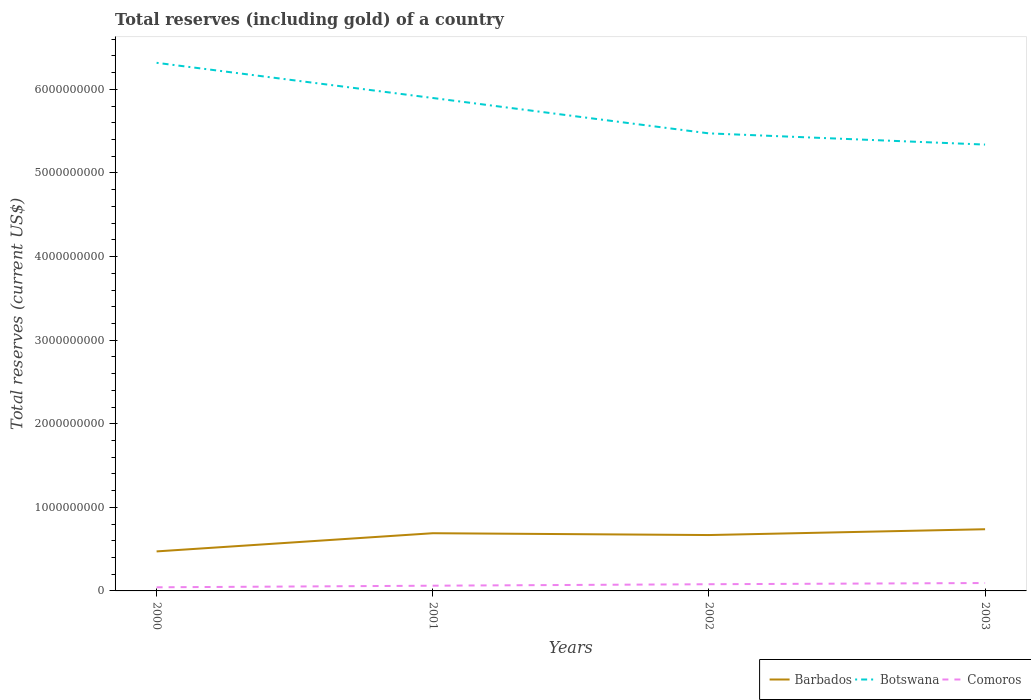Is the number of lines equal to the number of legend labels?
Your answer should be compact. Yes. Across all years, what is the maximum total reserves (including gold) in Barbados?
Offer a very short reply. 4.73e+08. In which year was the total reserves (including gold) in Comoros maximum?
Your response must be concise. 2000. What is the total total reserves (including gold) in Comoros in the graph?
Offer a terse response. -3.21e+07. What is the difference between the highest and the second highest total reserves (including gold) in Botswana?
Your response must be concise. 9.78e+08. What is the difference between the highest and the lowest total reserves (including gold) in Barbados?
Give a very brief answer. 3. How many years are there in the graph?
Your response must be concise. 4. What is the difference between two consecutive major ticks on the Y-axis?
Your response must be concise. 1.00e+09. Are the values on the major ticks of Y-axis written in scientific E-notation?
Your response must be concise. No. Does the graph contain any zero values?
Provide a short and direct response. No. Does the graph contain grids?
Ensure brevity in your answer.  No. How many legend labels are there?
Give a very brief answer. 3. How are the legend labels stacked?
Provide a short and direct response. Horizontal. What is the title of the graph?
Offer a very short reply. Total reserves (including gold) of a country. Does "Low & middle income" appear as one of the legend labels in the graph?
Offer a very short reply. No. What is the label or title of the Y-axis?
Your answer should be very brief. Total reserves (current US$). What is the Total reserves (current US$) of Barbados in 2000?
Your answer should be compact. 4.73e+08. What is the Total reserves (current US$) of Botswana in 2000?
Give a very brief answer. 6.32e+09. What is the Total reserves (current US$) in Comoros in 2000?
Your answer should be compact. 4.34e+07. What is the Total reserves (current US$) of Barbados in 2001?
Your answer should be compact. 6.90e+08. What is the Total reserves (current US$) of Botswana in 2001?
Ensure brevity in your answer.  5.90e+09. What is the Total reserves (current US$) of Comoros in 2001?
Your response must be concise. 6.25e+07. What is the Total reserves (current US$) in Barbados in 2002?
Keep it short and to the point. 6.69e+08. What is the Total reserves (current US$) in Botswana in 2002?
Provide a succinct answer. 5.47e+09. What is the Total reserves (current US$) in Comoros in 2002?
Your answer should be compact. 8.01e+07. What is the Total reserves (current US$) of Barbados in 2003?
Offer a terse response. 7.38e+08. What is the Total reserves (current US$) of Botswana in 2003?
Give a very brief answer. 5.34e+09. What is the Total reserves (current US$) of Comoros in 2003?
Give a very brief answer. 9.45e+07. Across all years, what is the maximum Total reserves (current US$) of Barbados?
Your response must be concise. 7.38e+08. Across all years, what is the maximum Total reserves (current US$) in Botswana?
Provide a short and direct response. 6.32e+09. Across all years, what is the maximum Total reserves (current US$) of Comoros?
Offer a terse response. 9.45e+07. Across all years, what is the minimum Total reserves (current US$) in Barbados?
Your answer should be very brief. 4.73e+08. Across all years, what is the minimum Total reserves (current US$) in Botswana?
Give a very brief answer. 5.34e+09. Across all years, what is the minimum Total reserves (current US$) in Comoros?
Offer a very short reply. 4.34e+07. What is the total Total reserves (current US$) in Barbados in the graph?
Your answer should be very brief. 2.57e+09. What is the total Total reserves (current US$) of Botswana in the graph?
Your answer should be compact. 2.30e+1. What is the total Total reserves (current US$) in Comoros in the graph?
Your answer should be compact. 2.81e+08. What is the difference between the Total reserves (current US$) of Barbados in 2000 and that in 2001?
Offer a very short reply. -2.18e+08. What is the difference between the Total reserves (current US$) in Botswana in 2000 and that in 2001?
Keep it short and to the point. 4.21e+08. What is the difference between the Total reserves (current US$) in Comoros in 2000 and that in 2001?
Your answer should be compact. -1.91e+07. What is the difference between the Total reserves (current US$) of Barbados in 2000 and that in 2002?
Offer a very short reply. -1.96e+08. What is the difference between the Total reserves (current US$) in Botswana in 2000 and that in 2002?
Give a very brief answer. 8.44e+08. What is the difference between the Total reserves (current US$) in Comoros in 2000 and that in 2002?
Your response must be concise. -3.68e+07. What is the difference between the Total reserves (current US$) in Barbados in 2000 and that in 2003?
Your answer should be compact. -2.65e+08. What is the difference between the Total reserves (current US$) in Botswana in 2000 and that in 2003?
Your response must be concise. 9.78e+08. What is the difference between the Total reserves (current US$) of Comoros in 2000 and that in 2003?
Offer a terse response. -5.12e+07. What is the difference between the Total reserves (current US$) of Barbados in 2001 and that in 2002?
Ensure brevity in your answer.  2.19e+07. What is the difference between the Total reserves (current US$) of Botswana in 2001 and that in 2002?
Keep it short and to the point. 4.23e+08. What is the difference between the Total reserves (current US$) in Comoros in 2001 and that in 2002?
Offer a very short reply. -1.77e+07. What is the difference between the Total reserves (current US$) in Barbados in 2001 and that in 2003?
Ensure brevity in your answer.  -4.76e+07. What is the difference between the Total reserves (current US$) in Botswana in 2001 and that in 2003?
Your response must be concise. 5.57e+08. What is the difference between the Total reserves (current US$) in Comoros in 2001 and that in 2003?
Offer a very short reply. -3.21e+07. What is the difference between the Total reserves (current US$) of Barbados in 2002 and that in 2003?
Keep it short and to the point. -6.94e+07. What is the difference between the Total reserves (current US$) of Botswana in 2002 and that in 2003?
Provide a succinct answer. 1.34e+08. What is the difference between the Total reserves (current US$) of Comoros in 2002 and that in 2003?
Make the answer very short. -1.44e+07. What is the difference between the Total reserves (current US$) of Barbados in 2000 and the Total reserves (current US$) of Botswana in 2001?
Keep it short and to the point. -5.42e+09. What is the difference between the Total reserves (current US$) of Barbados in 2000 and the Total reserves (current US$) of Comoros in 2001?
Keep it short and to the point. 4.10e+08. What is the difference between the Total reserves (current US$) of Botswana in 2000 and the Total reserves (current US$) of Comoros in 2001?
Offer a very short reply. 6.26e+09. What is the difference between the Total reserves (current US$) of Barbados in 2000 and the Total reserves (current US$) of Botswana in 2002?
Your answer should be very brief. -5.00e+09. What is the difference between the Total reserves (current US$) of Barbados in 2000 and the Total reserves (current US$) of Comoros in 2002?
Your answer should be very brief. 3.93e+08. What is the difference between the Total reserves (current US$) of Botswana in 2000 and the Total reserves (current US$) of Comoros in 2002?
Offer a terse response. 6.24e+09. What is the difference between the Total reserves (current US$) of Barbados in 2000 and the Total reserves (current US$) of Botswana in 2003?
Your answer should be very brief. -4.87e+09. What is the difference between the Total reserves (current US$) of Barbados in 2000 and the Total reserves (current US$) of Comoros in 2003?
Provide a short and direct response. 3.78e+08. What is the difference between the Total reserves (current US$) of Botswana in 2000 and the Total reserves (current US$) of Comoros in 2003?
Keep it short and to the point. 6.22e+09. What is the difference between the Total reserves (current US$) in Barbados in 2001 and the Total reserves (current US$) in Botswana in 2002?
Offer a terse response. -4.78e+09. What is the difference between the Total reserves (current US$) of Barbados in 2001 and the Total reserves (current US$) of Comoros in 2002?
Offer a very short reply. 6.10e+08. What is the difference between the Total reserves (current US$) of Botswana in 2001 and the Total reserves (current US$) of Comoros in 2002?
Provide a succinct answer. 5.82e+09. What is the difference between the Total reserves (current US$) of Barbados in 2001 and the Total reserves (current US$) of Botswana in 2003?
Provide a succinct answer. -4.65e+09. What is the difference between the Total reserves (current US$) in Barbados in 2001 and the Total reserves (current US$) in Comoros in 2003?
Ensure brevity in your answer.  5.96e+08. What is the difference between the Total reserves (current US$) of Botswana in 2001 and the Total reserves (current US$) of Comoros in 2003?
Offer a very short reply. 5.80e+09. What is the difference between the Total reserves (current US$) of Barbados in 2002 and the Total reserves (current US$) of Botswana in 2003?
Your answer should be very brief. -4.67e+09. What is the difference between the Total reserves (current US$) of Barbados in 2002 and the Total reserves (current US$) of Comoros in 2003?
Offer a terse response. 5.74e+08. What is the difference between the Total reserves (current US$) of Botswana in 2002 and the Total reserves (current US$) of Comoros in 2003?
Make the answer very short. 5.38e+09. What is the average Total reserves (current US$) in Barbados per year?
Your answer should be very brief. 6.42e+08. What is the average Total reserves (current US$) of Botswana per year?
Give a very brief answer. 5.76e+09. What is the average Total reserves (current US$) in Comoros per year?
Your answer should be compact. 7.01e+07. In the year 2000, what is the difference between the Total reserves (current US$) of Barbados and Total reserves (current US$) of Botswana?
Your answer should be compact. -5.85e+09. In the year 2000, what is the difference between the Total reserves (current US$) in Barbados and Total reserves (current US$) in Comoros?
Ensure brevity in your answer.  4.29e+08. In the year 2000, what is the difference between the Total reserves (current US$) in Botswana and Total reserves (current US$) in Comoros?
Your answer should be compact. 6.27e+09. In the year 2001, what is the difference between the Total reserves (current US$) of Barbados and Total reserves (current US$) of Botswana?
Make the answer very short. -5.21e+09. In the year 2001, what is the difference between the Total reserves (current US$) of Barbados and Total reserves (current US$) of Comoros?
Offer a very short reply. 6.28e+08. In the year 2001, what is the difference between the Total reserves (current US$) of Botswana and Total reserves (current US$) of Comoros?
Offer a terse response. 5.83e+09. In the year 2002, what is the difference between the Total reserves (current US$) in Barbados and Total reserves (current US$) in Botswana?
Make the answer very short. -4.81e+09. In the year 2002, what is the difference between the Total reserves (current US$) in Barbados and Total reserves (current US$) in Comoros?
Your answer should be compact. 5.88e+08. In the year 2002, what is the difference between the Total reserves (current US$) in Botswana and Total reserves (current US$) in Comoros?
Provide a short and direct response. 5.39e+09. In the year 2003, what is the difference between the Total reserves (current US$) of Barbados and Total reserves (current US$) of Botswana?
Provide a short and direct response. -4.60e+09. In the year 2003, what is the difference between the Total reserves (current US$) of Barbados and Total reserves (current US$) of Comoros?
Provide a succinct answer. 6.43e+08. In the year 2003, what is the difference between the Total reserves (current US$) in Botswana and Total reserves (current US$) in Comoros?
Provide a succinct answer. 5.25e+09. What is the ratio of the Total reserves (current US$) in Barbados in 2000 to that in 2001?
Provide a succinct answer. 0.68. What is the ratio of the Total reserves (current US$) in Botswana in 2000 to that in 2001?
Keep it short and to the point. 1.07. What is the ratio of the Total reserves (current US$) of Comoros in 2000 to that in 2001?
Offer a terse response. 0.69. What is the ratio of the Total reserves (current US$) in Barbados in 2000 to that in 2002?
Your response must be concise. 0.71. What is the ratio of the Total reserves (current US$) of Botswana in 2000 to that in 2002?
Ensure brevity in your answer.  1.15. What is the ratio of the Total reserves (current US$) in Comoros in 2000 to that in 2002?
Offer a very short reply. 0.54. What is the ratio of the Total reserves (current US$) of Barbados in 2000 to that in 2003?
Give a very brief answer. 0.64. What is the ratio of the Total reserves (current US$) in Botswana in 2000 to that in 2003?
Provide a succinct answer. 1.18. What is the ratio of the Total reserves (current US$) of Comoros in 2000 to that in 2003?
Ensure brevity in your answer.  0.46. What is the ratio of the Total reserves (current US$) in Barbados in 2001 to that in 2002?
Your answer should be very brief. 1.03. What is the ratio of the Total reserves (current US$) of Botswana in 2001 to that in 2002?
Your answer should be compact. 1.08. What is the ratio of the Total reserves (current US$) of Comoros in 2001 to that in 2002?
Your answer should be very brief. 0.78. What is the ratio of the Total reserves (current US$) in Barbados in 2001 to that in 2003?
Make the answer very short. 0.94. What is the ratio of the Total reserves (current US$) in Botswana in 2001 to that in 2003?
Keep it short and to the point. 1.1. What is the ratio of the Total reserves (current US$) of Comoros in 2001 to that in 2003?
Ensure brevity in your answer.  0.66. What is the ratio of the Total reserves (current US$) in Barbados in 2002 to that in 2003?
Give a very brief answer. 0.91. What is the ratio of the Total reserves (current US$) of Botswana in 2002 to that in 2003?
Your answer should be very brief. 1.03. What is the ratio of the Total reserves (current US$) in Comoros in 2002 to that in 2003?
Provide a short and direct response. 0.85. What is the difference between the highest and the second highest Total reserves (current US$) of Barbados?
Provide a short and direct response. 4.76e+07. What is the difference between the highest and the second highest Total reserves (current US$) of Botswana?
Provide a succinct answer. 4.21e+08. What is the difference between the highest and the second highest Total reserves (current US$) in Comoros?
Provide a short and direct response. 1.44e+07. What is the difference between the highest and the lowest Total reserves (current US$) in Barbados?
Provide a succinct answer. 2.65e+08. What is the difference between the highest and the lowest Total reserves (current US$) in Botswana?
Your response must be concise. 9.78e+08. What is the difference between the highest and the lowest Total reserves (current US$) in Comoros?
Keep it short and to the point. 5.12e+07. 